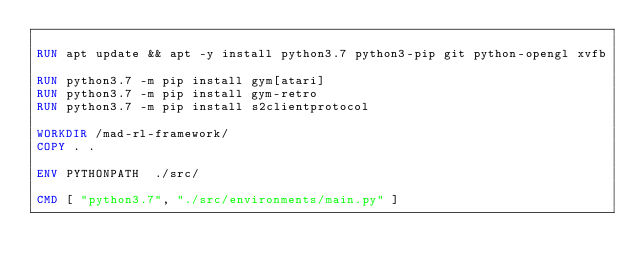Convert code to text. <code><loc_0><loc_0><loc_500><loc_500><_Dockerfile_>
RUN apt update && apt -y install python3.7 python3-pip git python-opengl xvfb

RUN python3.7 -m pip install gym[atari]
RUN python3.7 -m pip install gym-retro
RUN python3.7 -m pip install s2clientprotocol

WORKDIR /mad-rl-framework/
COPY . .

ENV PYTHONPATH  ./src/

CMD [ "python3.7", "./src/environments/main.py" ]
</code> 